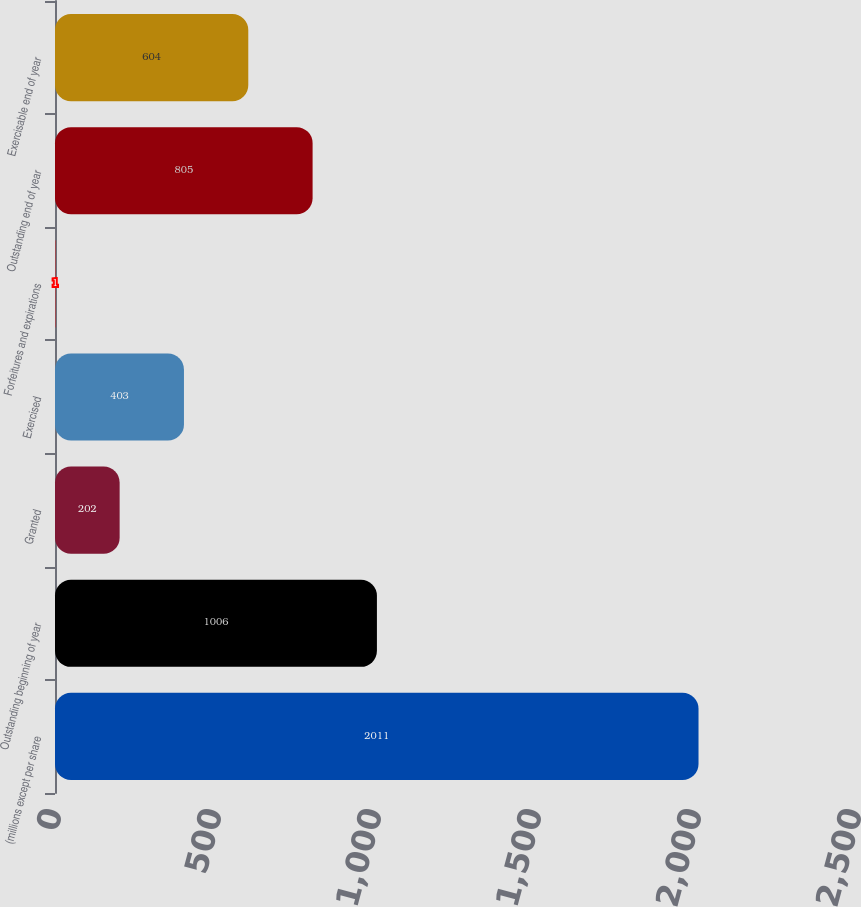<chart> <loc_0><loc_0><loc_500><loc_500><bar_chart><fcel>(millions except per share<fcel>Outstanding beginning of year<fcel>Granted<fcel>Exercised<fcel>Forfeitures and expirations<fcel>Outstanding end of year<fcel>Exercisable end of year<nl><fcel>2011<fcel>1006<fcel>202<fcel>403<fcel>1<fcel>805<fcel>604<nl></chart> 